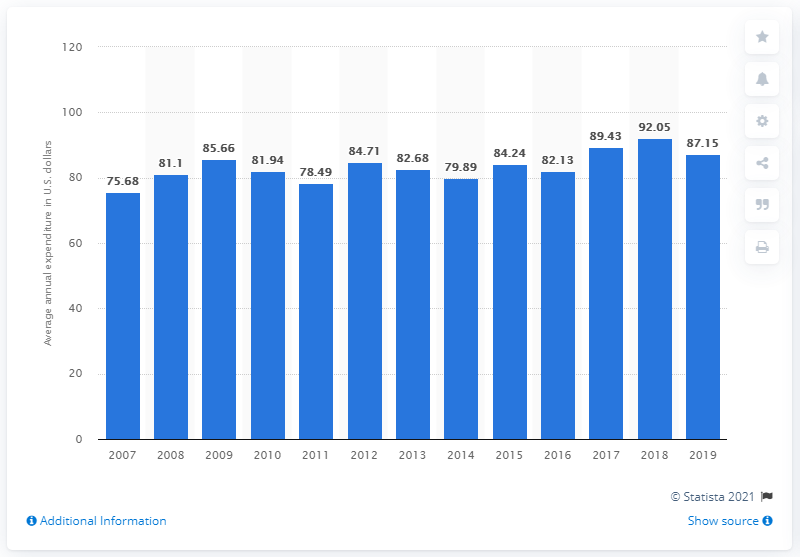Draw attention to some important aspects in this diagram. In the year 2017, consumer spending for soaps and detergents increased. 